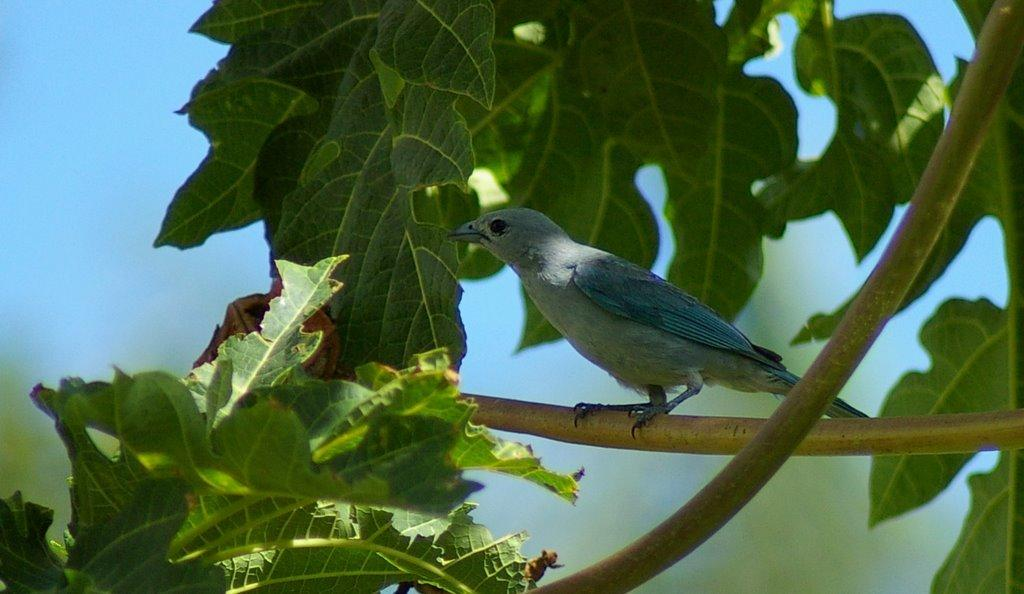What type of animal can be seen in the image? There is a bird in the image. Where is the bird located? The bird is on a tree. What is the weight of the rifle in the image? There is no rifle present in the image, so it is not possible to determine its weight. 